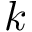Convert formula to latex. <formula><loc_0><loc_0><loc_500><loc_500>k</formula> 